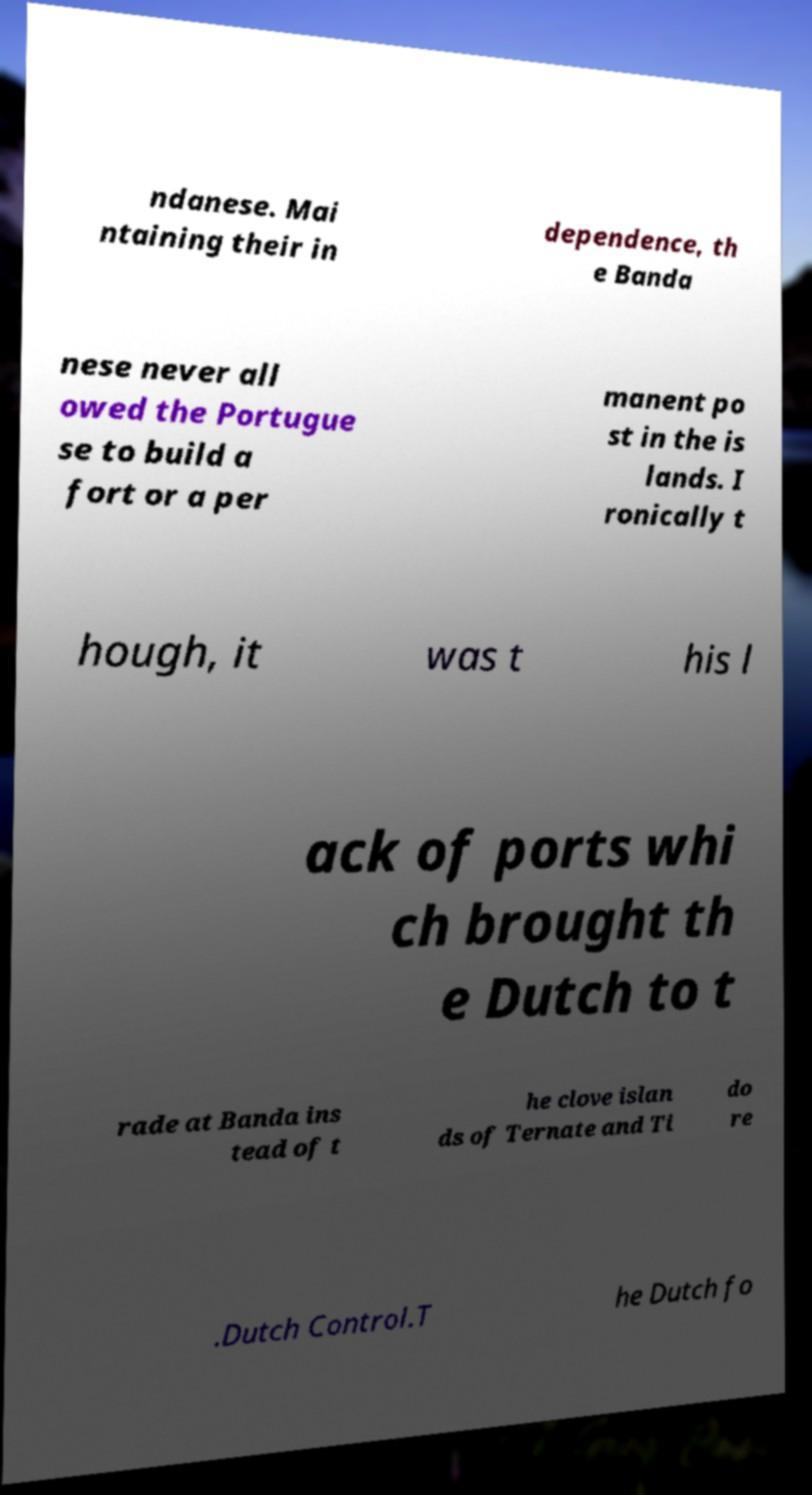There's text embedded in this image that I need extracted. Can you transcribe it verbatim? ndanese. Mai ntaining their in dependence, th e Banda nese never all owed the Portugue se to build a fort or a per manent po st in the is lands. I ronically t hough, it was t his l ack of ports whi ch brought th e Dutch to t rade at Banda ins tead of t he clove islan ds of Ternate and Ti do re .Dutch Control.T he Dutch fo 